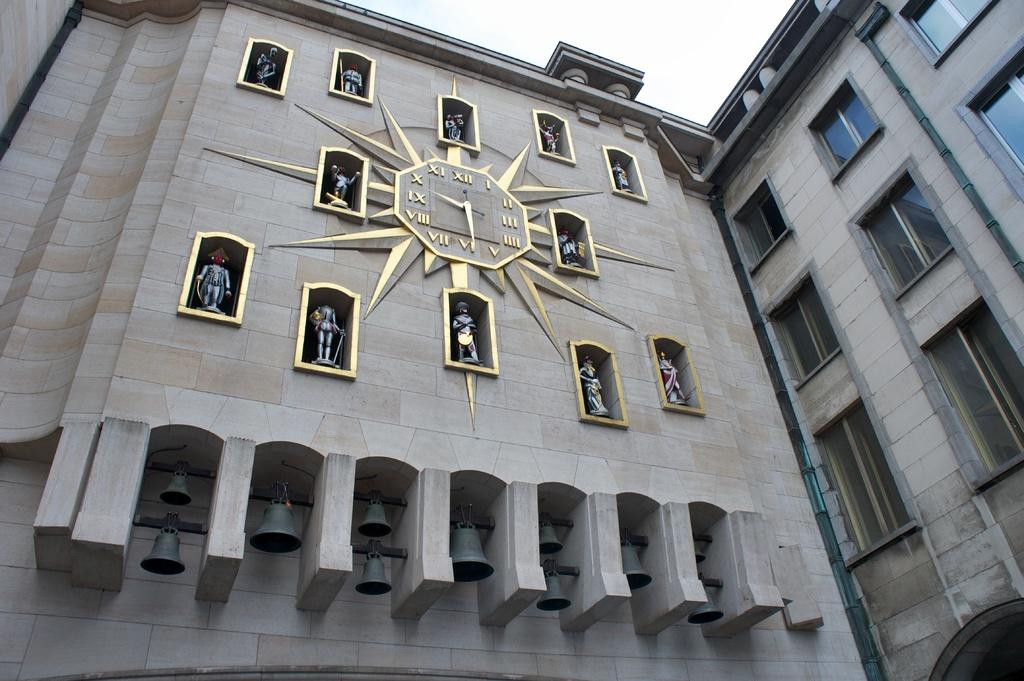What type of structure is present in the image? There is a building in the image. What time-telling device can be seen in the image? There is a clock in the image. What artistic objects are featured in the image? There are sculptures in the image. What other objects are present in the image that are related to the clock? There are bells in the image. What can be seen in the background of the image? The sky is visible in the background of the image. What is the rate of the example request in the image? There is no example or request present in the image; it features a building, a clock, sculptures, bells, and a visible sky. 